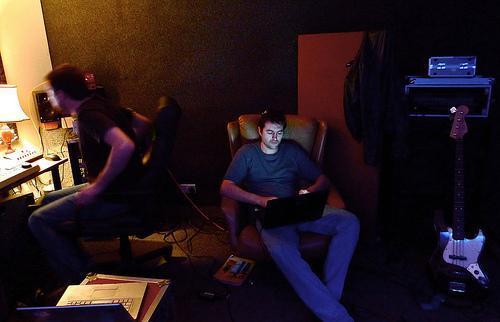How many guitars?
Give a very brief answer. 1. How many laptops are shown?
Give a very brief answer. 2. How many chairs are there?
Give a very brief answer. 2. 